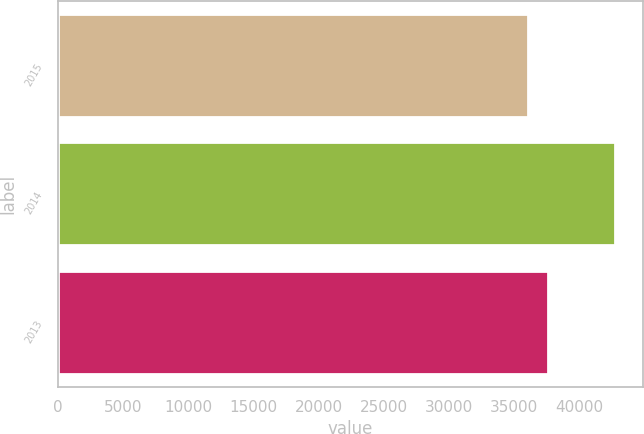Convert chart to OTSL. <chart><loc_0><loc_0><loc_500><loc_500><bar_chart><fcel>2015<fcel>2014<fcel>2013<nl><fcel>36074<fcel>42765<fcel>37627<nl></chart> 